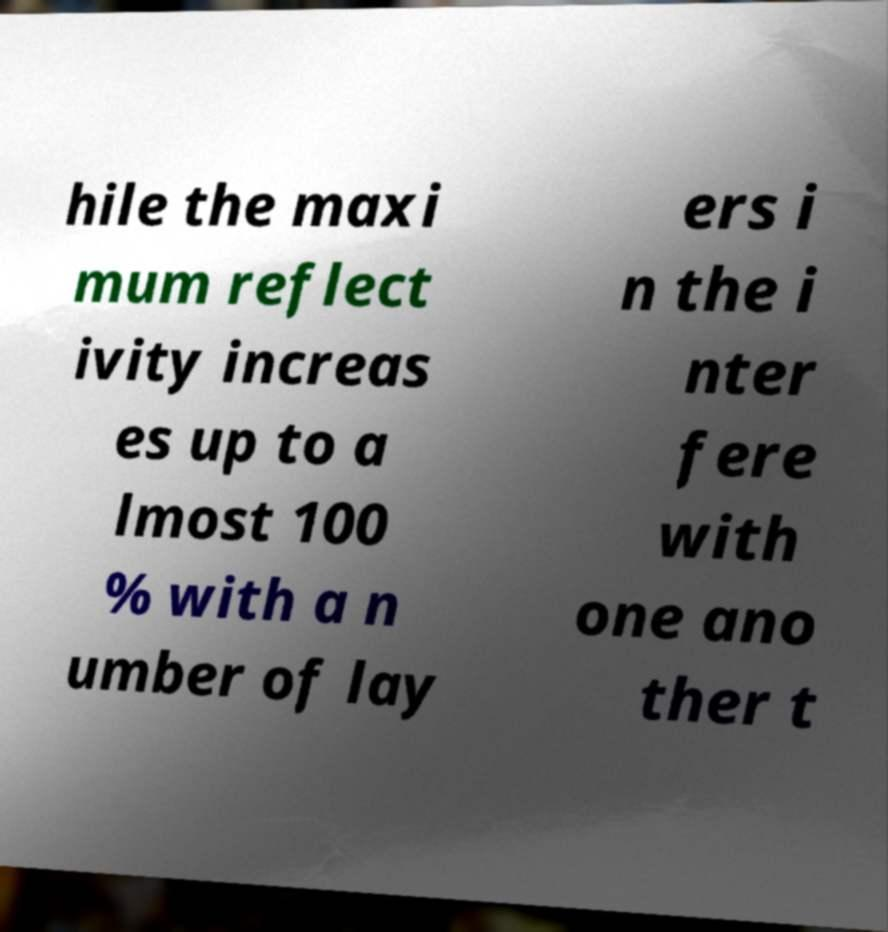Please read and relay the text visible in this image. What does it say? hile the maxi mum reflect ivity increas es up to a lmost 100 % with a n umber of lay ers i n the i nter fere with one ano ther t 